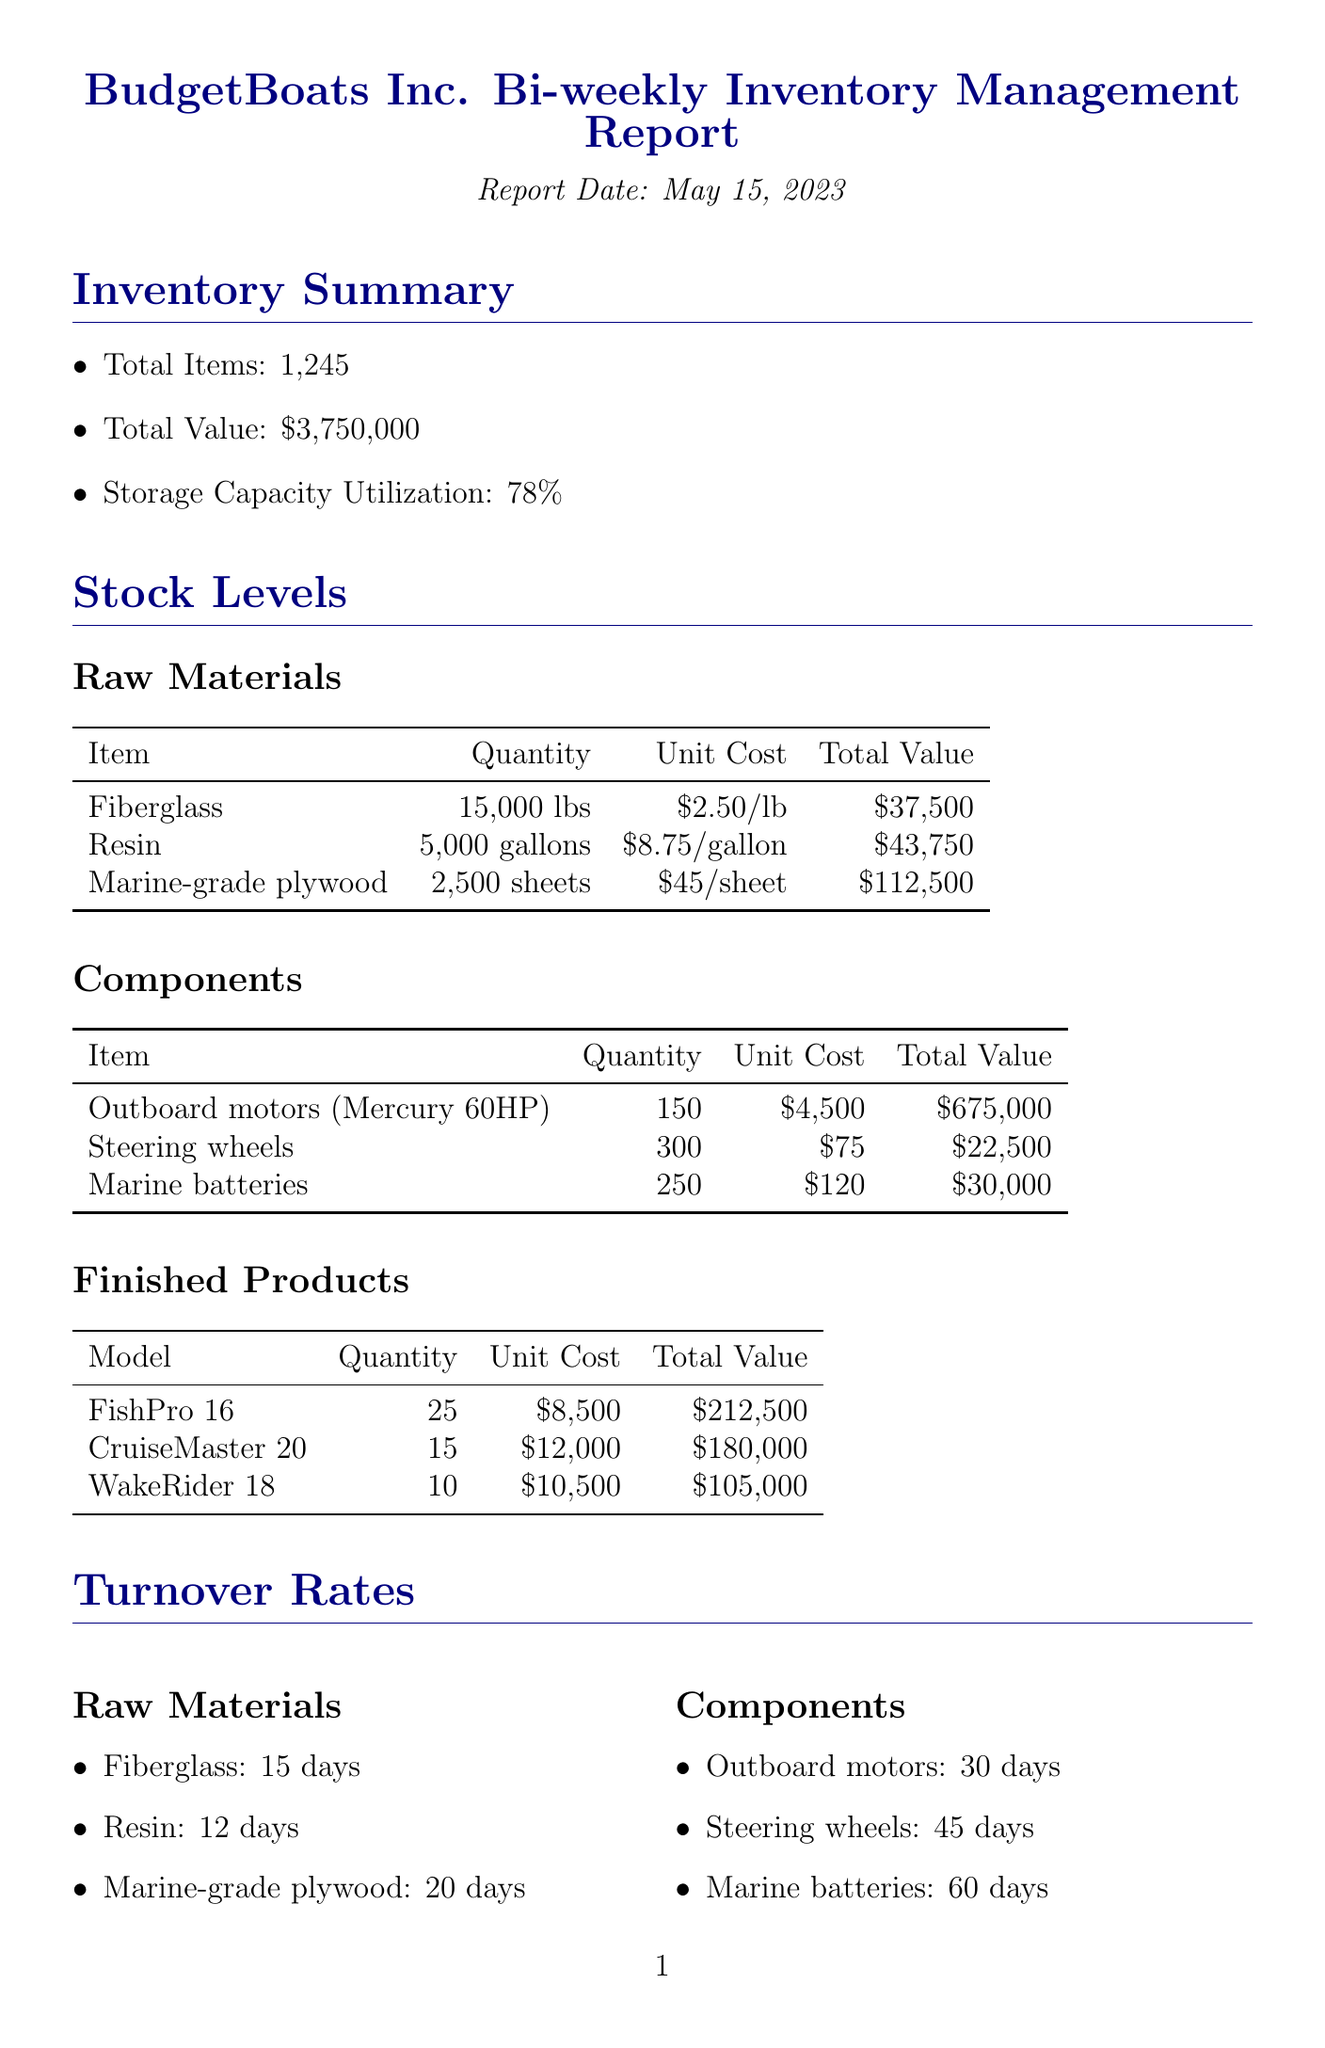what is the total value of inventory? The total value of inventory is listed in the document as $3,750,000.
Answer: $3,750,000 how many units of Marine-grade plywood are in stock? The document specifies there are 2,500 sheets of Marine-grade plywood in stock.
Answer: 2,500 sheets what is the lead time for obtaining Fiberglass? The lead time for obtaining Fiberglass according to the document is 7 days.
Answer: 7 days which model has the highest quantity available in finished products? The document states that the FishPro 16 has the highest quantity available, with 25 units in stock.
Answer: FishPro 16 what is the forecasted quantity of Outboard motors needed for the upcoming production cycle? For the upcoming production cycle, the forecasted quantity of Outboard motors needed is 120 units.
Answer: 120 how many total items are in inventory? The total number of items in inventory is provided as 1,245.
Answer: 1,245 what is the turnover rate for Marine batteries? The turnover rate for Marine batteries is stated as 60 days in the document.
Answer: 60 days what are two inventory challenges mentioned in the report? The report cites "Fluctuating demand for different boat models" and "Long lead times for certain components" as two inventory challenges.
Answer: Fluctuating demand for different boat models, Long lead times for certain components what is the minimum order quantity for Outboard motors? The minimum order quantity for Outboard motors is listed as 50 units.
Answer: 50 units 